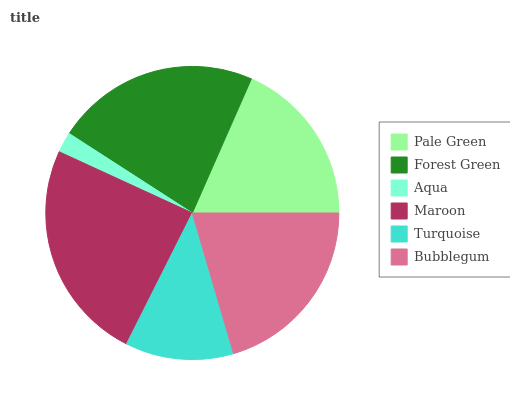Is Aqua the minimum?
Answer yes or no. Yes. Is Maroon the maximum?
Answer yes or no. Yes. Is Forest Green the minimum?
Answer yes or no. No. Is Forest Green the maximum?
Answer yes or no. No. Is Forest Green greater than Pale Green?
Answer yes or no. Yes. Is Pale Green less than Forest Green?
Answer yes or no. Yes. Is Pale Green greater than Forest Green?
Answer yes or no. No. Is Forest Green less than Pale Green?
Answer yes or no. No. Is Bubblegum the high median?
Answer yes or no. Yes. Is Pale Green the low median?
Answer yes or no. Yes. Is Pale Green the high median?
Answer yes or no. No. Is Maroon the low median?
Answer yes or no. No. 